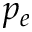<formula> <loc_0><loc_0><loc_500><loc_500>p _ { e }</formula> 